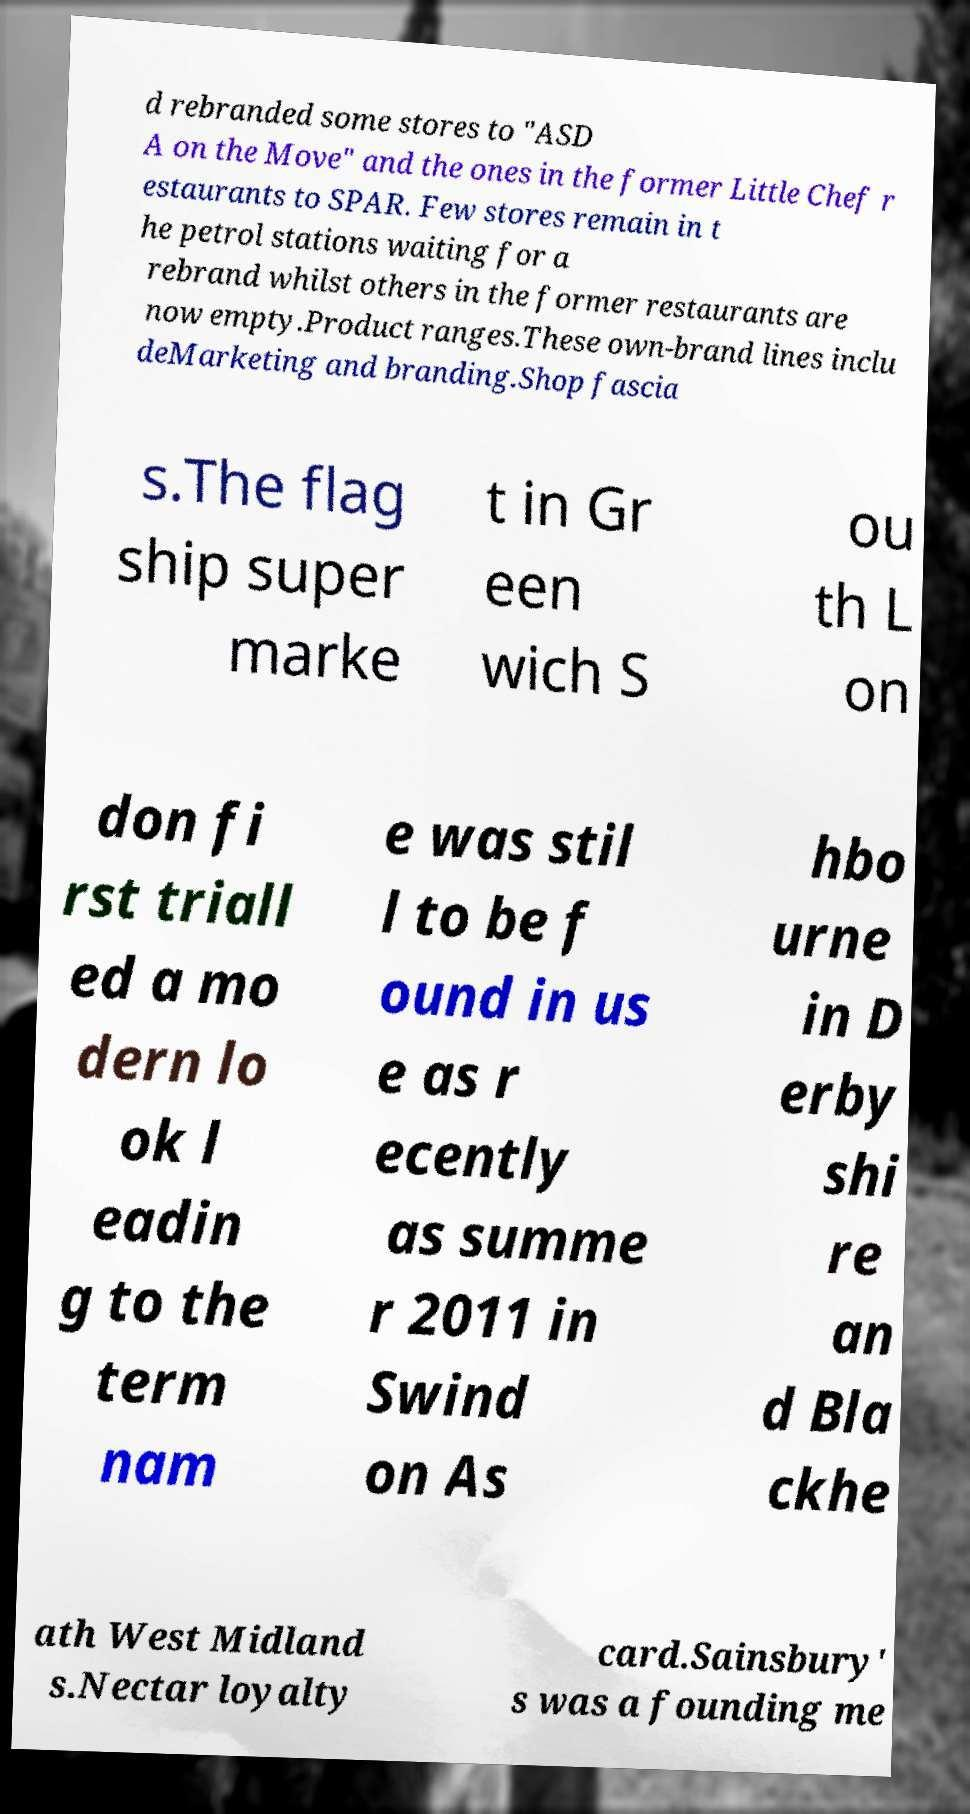There's text embedded in this image that I need extracted. Can you transcribe it verbatim? d rebranded some stores to "ASD A on the Move" and the ones in the former Little Chef r estaurants to SPAR. Few stores remain in t he petrol stations waiting for a rebrand whilst others in the former restaurants are now empty.Product ranges.These own-brand lines inclu deMarketing and branding.Shop fascia s.The flag ship super marke t in Gr een wich S ou th L on don fi rst triall ed a mo dern lo ok l eadin g to the term nam e was stil l to be f ound in us e as r ecently as summe r 2011 in Swind on As hbo urne in D erby shi re an d Bla ckhe ath West Midland s.Nectar loyalty card.Sainsbury' s was a founding me 